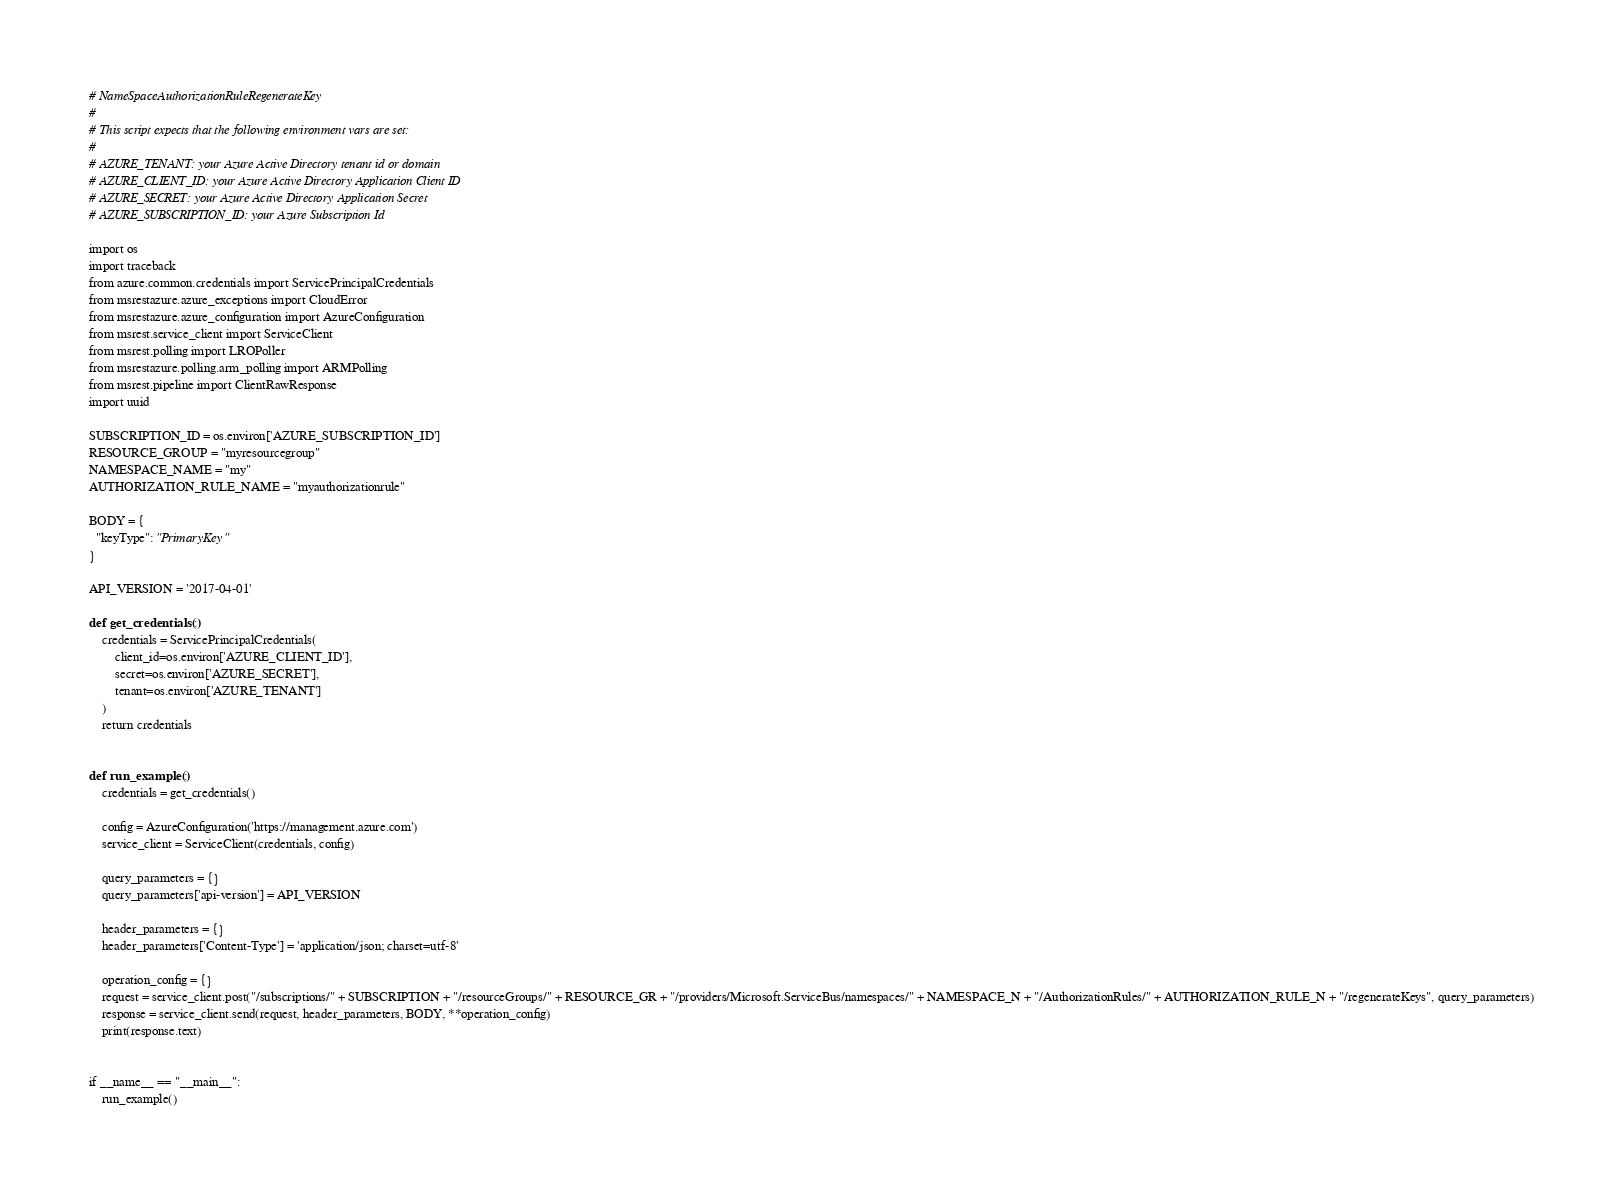<code> <loc_0><loc_0><loc_500><loc_500><_YAML_># NameSpaceAuthorizationRuleRegenerateKey
#
# This script expects that the following environment vars are set:
#
# AZURE_TENANT: your Azure Active Directory tenant id or domain
# AZURE_CLIENT_ID: your Azure Active Directory Application Client ID
# AZURE_SECRET: your Azure Active Directory Application Secret
# AZURE_SUBSCRIPTION_ID: your Azure Subscription Id

import os
import traceback
from azure.common.credentials import ServicePrincipalCredentials
from msrestazure.azure_exceptions import CloudError
from msrestazure.azure_configuration import AzureConfiguration
from msrest.service_client import ServiceClient
from msrest.polling import LROPoller
from msrestazure.polling.arm_polling import ARMPolling
from msrest.pipeline import ClientRawResponse
import uuid

SUBSCRIPTION_ID = os.environ['AZURE_SUBSCRIPTION_ID']
RESOURCE_GROUP = "myresourcegroup"
NAMESPACE_NAME = "my"
AUTHORIZATION_RULE_NAME = "myauthorizationrule"

BODY = {
  "keyType": "PrimaryKey"
}

API_VERSION = '2017-04-01'

def get_credentials():
    credentials = ServicePrincipalCredentials(
        client_id=os.environ['AZURE_CLIENT_ID'],
        secret=os.environ['AZURE_SECRET'],
        tenant=os.environ['AZURE_TENANT']
    )
    return credentials


def run_example():
    credentials = get_credentials()

    config = AzureConfiguration('https://management.azure.com')
    service_client = ServiceClient(credentials, config)

    query_parameters = {}
    query_parameters['api-version'] = API_VERSION

    header_parameters = {}
    header_parameters['Content-Type'] = 'application/json; charset=utf-8'

    operation_config = {}
    request = service_client.post("/subscriptions/" + SUBSCRIPTION + "/resourceGroups/" + RESOURCE_GR + "/providers/Microsoft.ServiceBus/namespaces/" + NAMESPACE_N + "/AuthorizationRules/" + AUTHORIZATION_RULE_N + "/regenerateKeys", query_parameters)
    response = service_client.send(request, header_parameters, BODY, **operation_config)
    print(response.text)


if __name__ == "__main__":
    run_example()</code> 